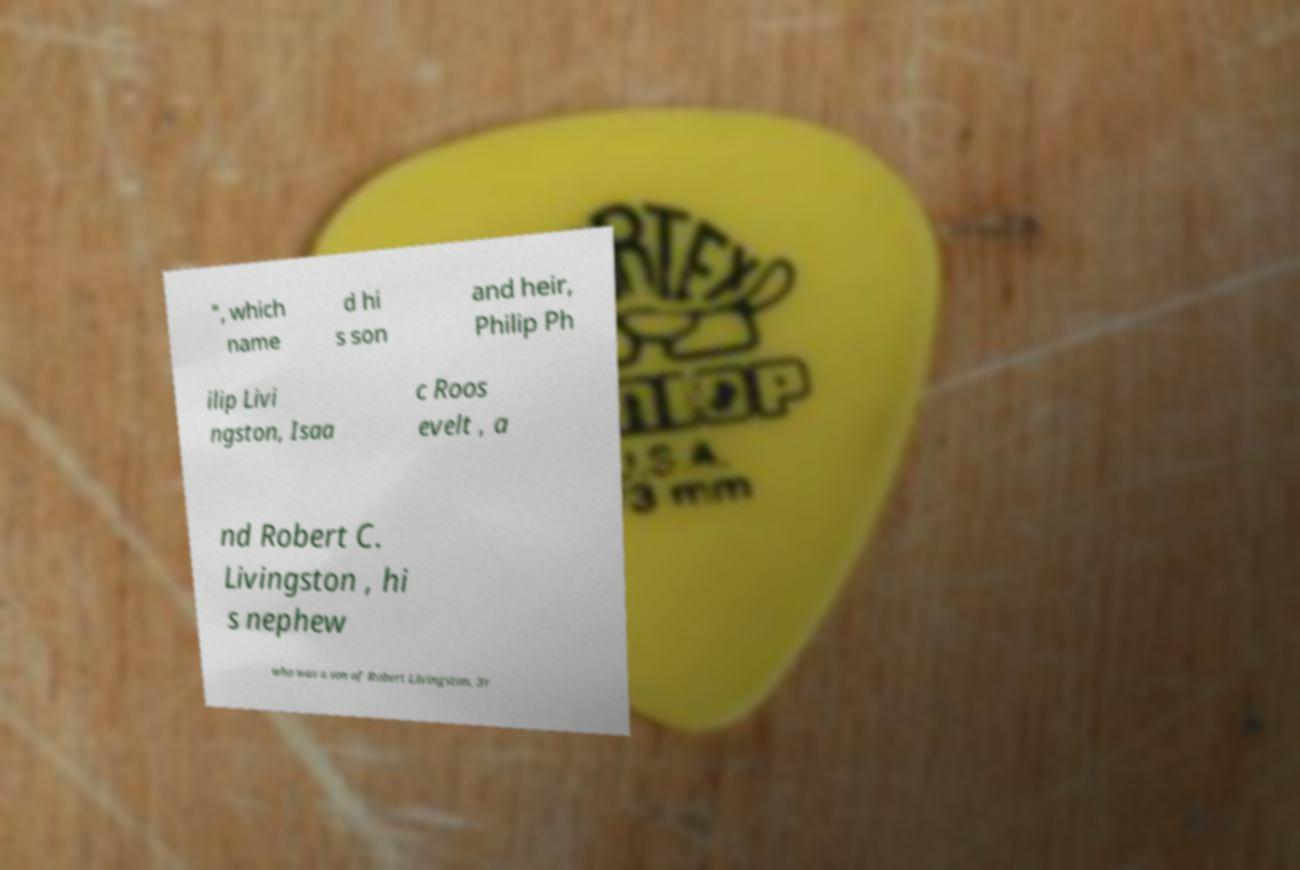Could you assist in decoding the text presented in this image and type it out clearly? ", which name d hi s son and heir, Philip Ph ilip Livi ngston, Isaa c Roos evelt , a nd Robert C. Livingston , hi s nephew who was a son of Robert Livingston, 3r 